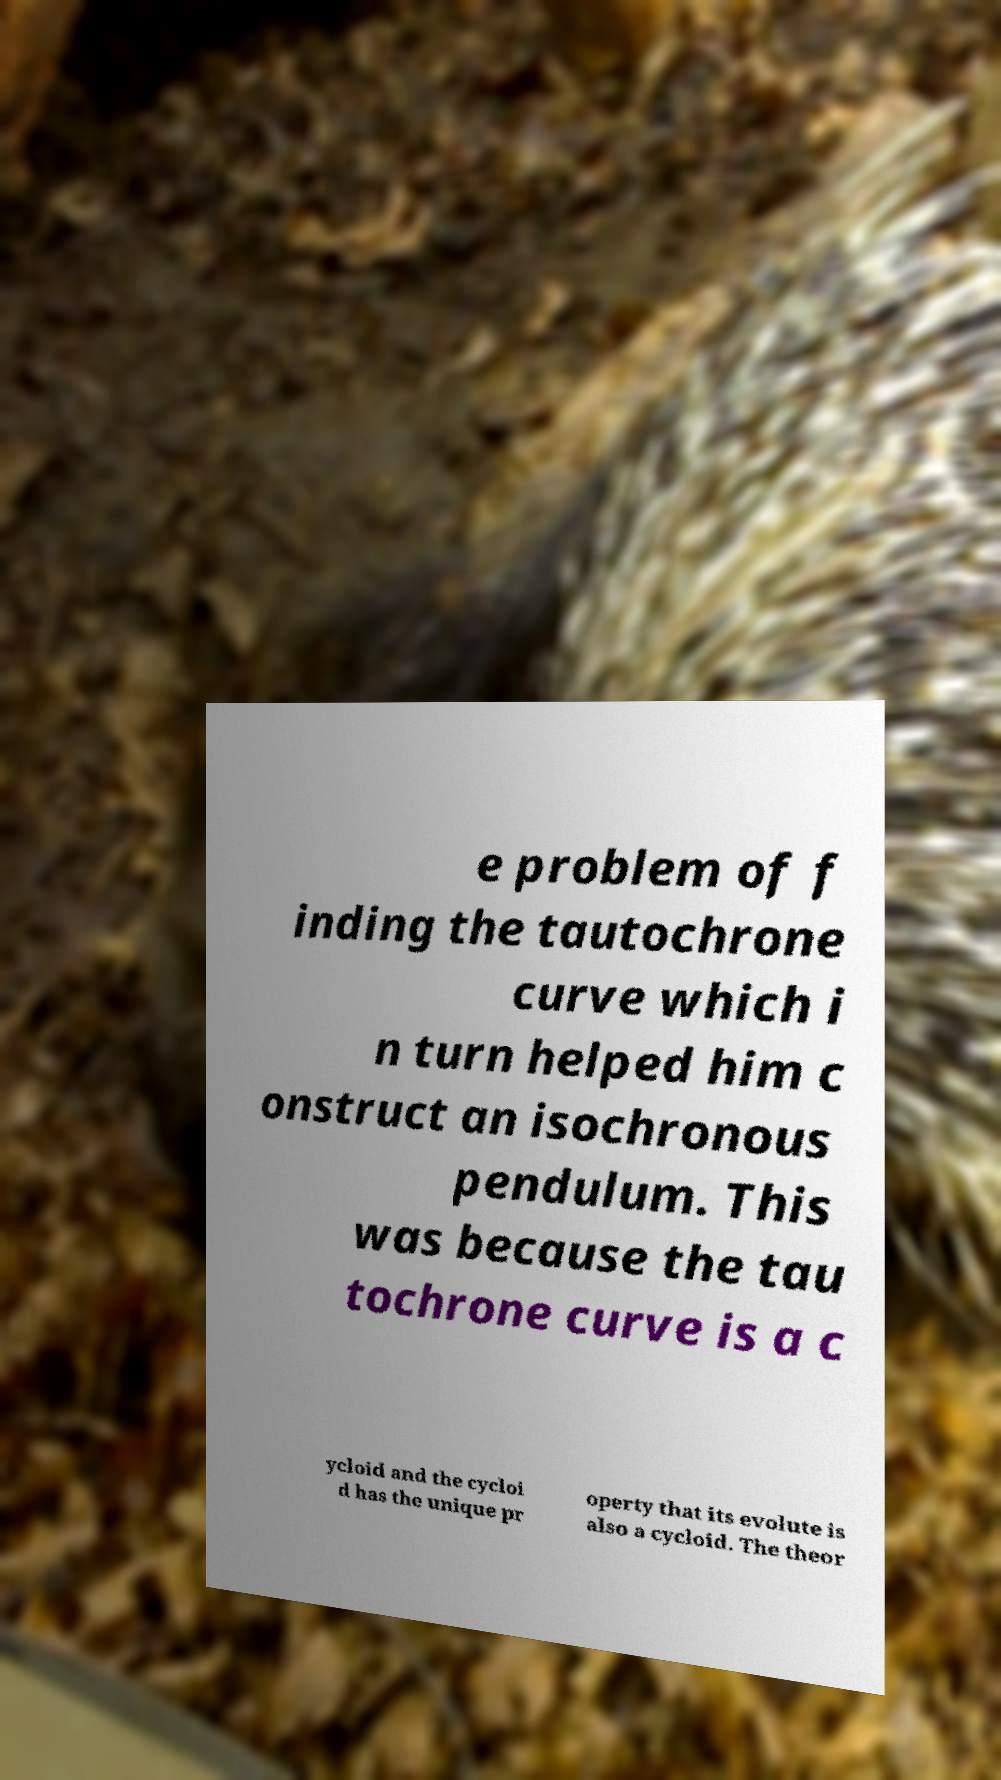There's text embedded in this image that I need extracted. Can you transcribe it verbatim? e problem of f inding the tautochrone curve which i n turn helped him c onstruct an isochronous pendulum. This was because the tau tochrone curve is a c ycloid and the cycloi d has the unique pr operty that its evolute is also a cycloid. The theor 